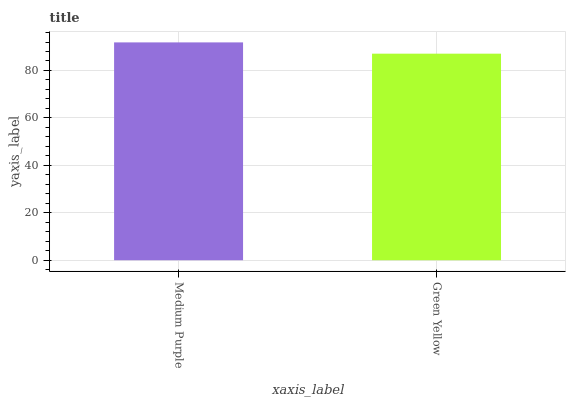Is Green Yellow the minimum?
Answer yes or no. Yes. Is Medium Purple the maximum?
Answer yes or no. Yes. Is Green Yellow the maximum?
Answer yes or no. No. Is Medium Purple greater than Green Yellow?
Answer yes or no. Yes. Is Green Yellow less than Medium Purple?
Answer yes or no. Yes. Is Green Yellow greater than Medium Purple?
Answer yes or no. No. Is Medium Purple less than Green Yellow?
Answer yes or no. No. Is Medium Purple the high median?
Answer yes or no. Yes. Is Green Yellow the low median?
Answer yes or no. Yes. Is Green Yellow the high median?
Answer yes or no. No. Is Medium Purple the low median?
Answer yes or no. No. 